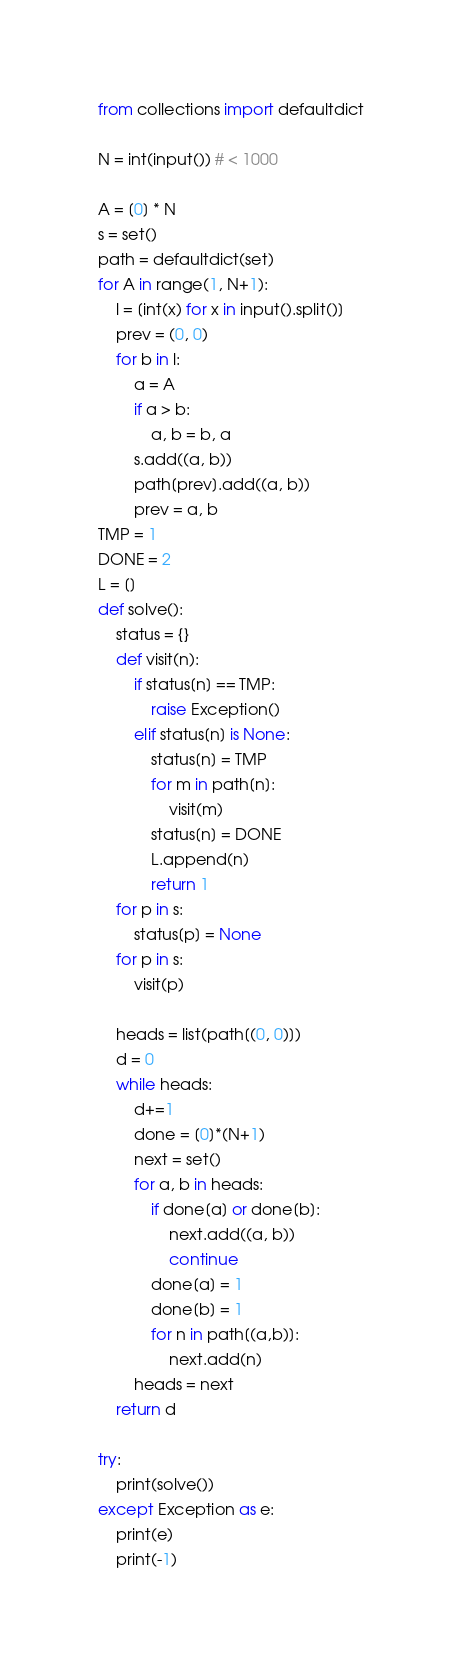<code> <loc_0><loc_0><loc_500><loc_500><_Python_>from collections import defaultdict

N = int(input()) # < 1000

A = [0] * N
s = set()
path = defaultdict(set)
for A in range(1, N+1):
    l = [int(x) for x in input().split()]
    prev = (0, 0)
    for b in l:
        a = A
        if a > b:
            a, b = b, a
        s.add((a, b))
        path[prev].add((a, b))
        prev = a, b
TMP = 1
DONE = 2
L = []
def solve():
    status = {}
    def visit(n):
        if status[n] == TMP:
            raise Exception()
        elif status[n] is None:
            status[n] = TMP
            for m in path[n]:
                visit(m)
            status[n] = DONE
            L.append(n)
            return 1
    for p in s:
        status[p] = None
    for p in s:
        visit(p)

    heads = list(path[(0, 0)])
    d = 0
    while heads:
        d+=1
        done = [0]*(N+1)
        next = set()
        for a, b in heads:
            if done[a] or done[b]:
                next.add((a, b))
                continue
            done[a] = 1
            done[b] = 1
            for n in path[(a,b)]:
                next.add(n)
        heads = next
    return d 

try:
    print(solve())
except Exception as e:
    print(e)
    print(-1)






</code> 